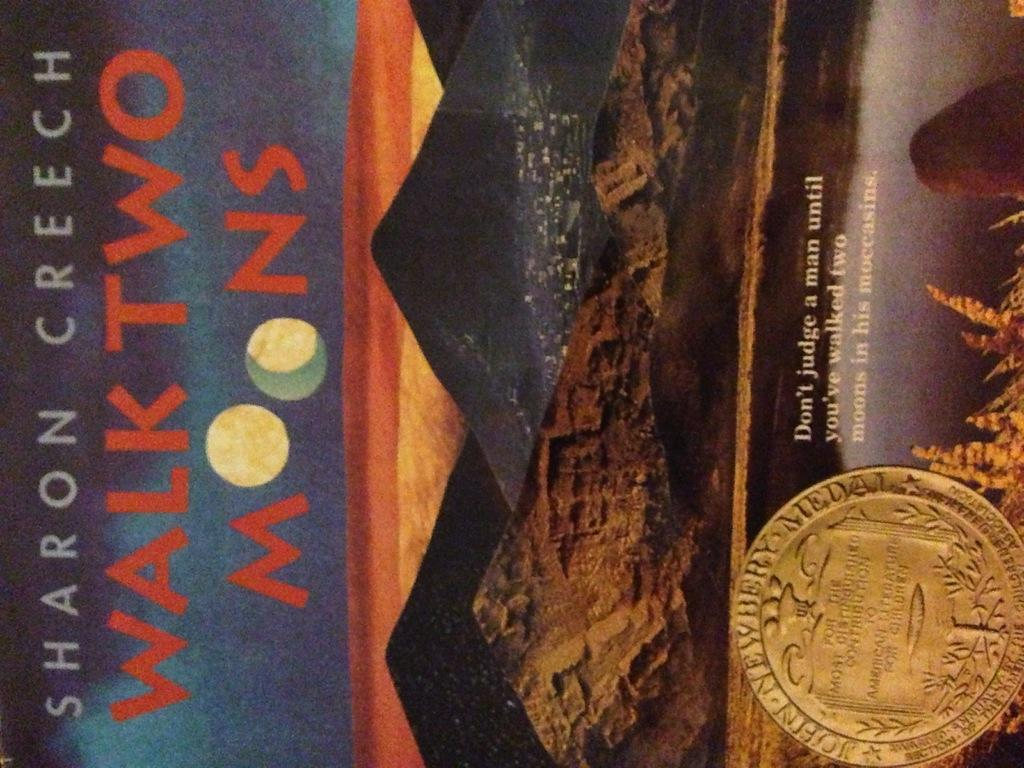Provide a one-sentence caption for the provided image. A book cover of Walk Two Moons by Sharon Creech. 